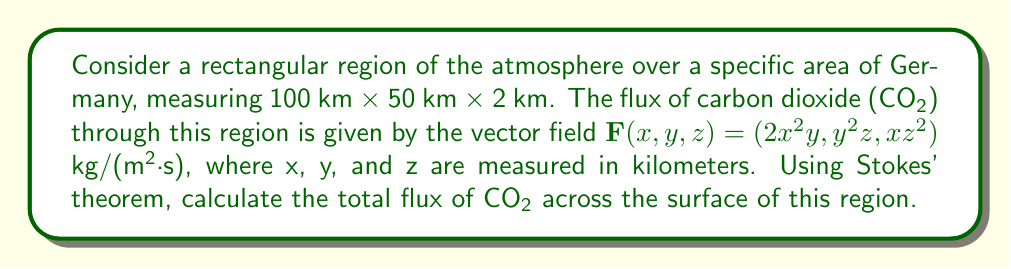Teach me how to tackle this problem. To solve this problem, we'll use Stokes' theorem, which relates the surface integral of the curl of a vector field over a surface to the line integral of the vector field around the boundary of the surface.

1) First, we need to calculate the curl of $\mathbf{F}$:

   $$\text{curl }\mathbf{F} = \nabla \times \mathbf{F} = \left(\frac{\partial F_z}{\partial y} - \frac{\partial F_y}{\partial z}, \frac{\partial F_x}{\partial z} - \frac{\partial F_z}{\partial x}, \frac{\partial F_y}{\partial x} - \frac{\partial F_x}{\partial y}\right)$$

   $$\text{curl }\mathbf{F} = (z^2 - y^2, 0, 4xy - 2x^2)$$

2) Now, we need to integrate this curl over the surface. The surface consists of six rectangular faces. Due to symmetry, we only need to consider the top and bottom faces (xy-plane) and two side faces (xz-plane and yz-plane).

3) For the top and bottom faces (z = 2 and z = 0, respectively):

   $$\iint_{S_{top}} \text{curl }\mathbf{F} \cdot d\mathbf{S} = \int_0^{50} \int_0^{100} (4 - y^2) \, dx \, dy$$
   $$\iint_{S_{bottom}} \text{curl }\mathbf{F} \cdot d\mathbf{S} = -\int_0^{50} \int_0^{100} (0 - y^2) \, dx \, dy$$

4) For the side face in the xz-plane (y = 50):

   $$\iint_{S_{side1}} \text{curl }\mathbf{F} \cdot d\mathbf{S} = \int_0^2 \int_0^{100} (200x - 2x^2) \, dx \, dz$$

5) For the side face in the yz-plane (x = 100):

   $$\iint_{S_{side2}} \text{curl }\mathbf{F} \cdot d\mathbf{S} = -\int_0^2 \int_0^{50} (400y - 20000) \, dy \, dz$$

6) Evaluating these integrals:

   Top and bottom: $100 \cdot 50 \cdot 4 - \frac{100 \cdot 50^3}{3} = 8333.33$ kg/s
   Side1: $\frac{200 \cdot 100^2 \cdot 2}{2} - \frac{2 \cdot 100^3 \cdot 2}{3} = 666666.67$ kg/s
   Side2: $-400 \cdot 50^2 \cdot 2 + 20000 \cdot 50 \cdot 2 = -1000000$ kg/s

7) Sum all the contributions:

   Total flux = 8333.33 + 666666.67 - 1000000 = -325000 kg/s

The negative sign indicates that there is a net inflow of CO₂ into the region.
Answer: The total flux of CO₂ across the surface of the region is -325,000 kg/s, indicating a net inflow of carbon dioxide into the specified atmospheric volume. 